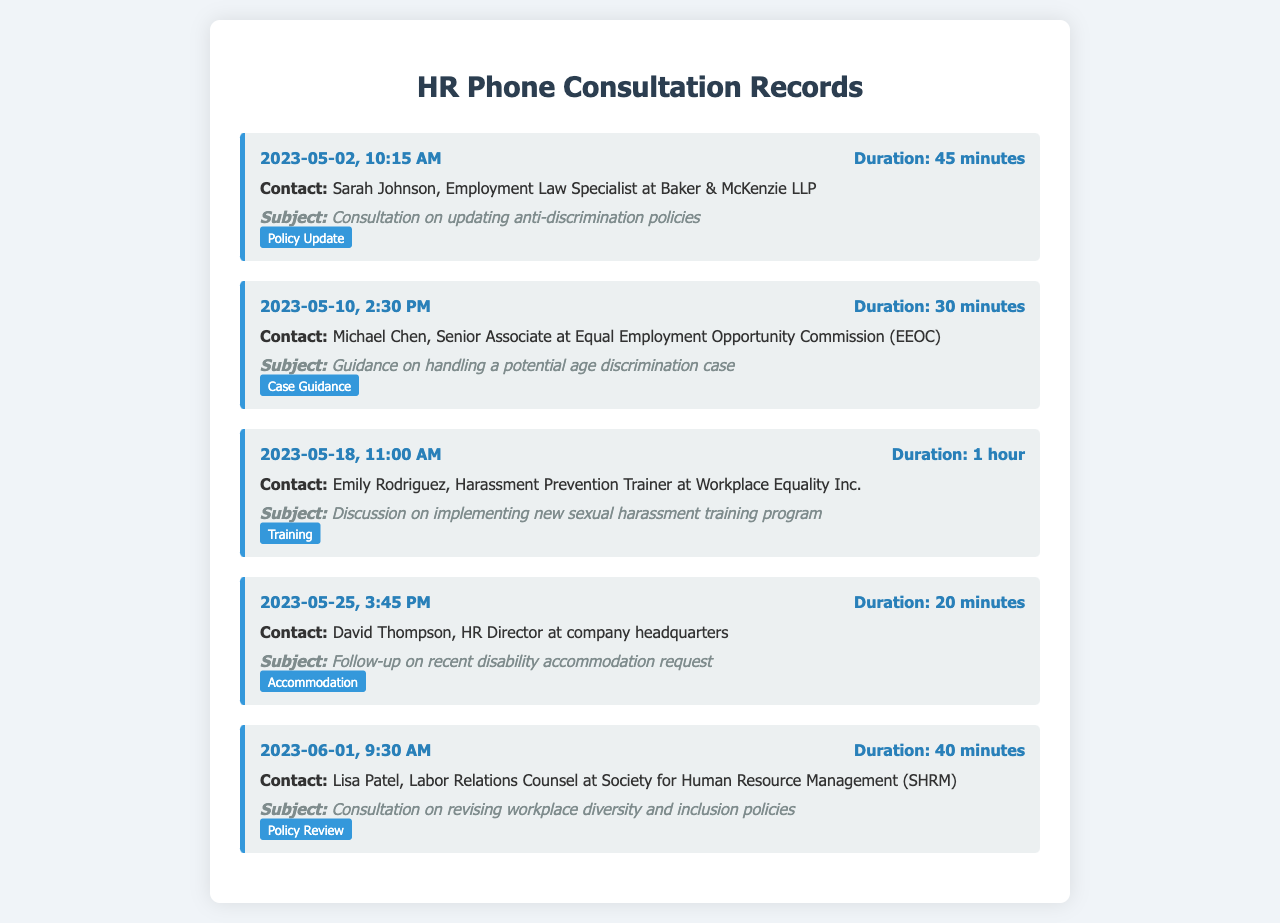what is the date of the consultation with Sarah Johnson? The consultation with Sarah Johnson occurred on May 2, 2023.
Answer: May 2, 2023 who did the HR associate consult regarding a potential age discrimination case? The HR associate consulted Michael Chen regarding a potential age discrimination case.
Answer: Michael Chen how long was the consultation about the new sexual harassment training program? The consultation about the new sexual harassment training program lasted 1 hour.
Answer: 1 hour which organization is Emily Rodriguez affiliated with? Emily Rodriguez is affiliated with Workplace Equality Inc.
Answer: Workplace Equality Inc what is the subject of the call on May 25, 2023? The subject of the call on May 25, 2023, was a follow-up on a recent disability accommodation request.
Answer: Follow-up on recent disability accommodation request how many minutes were spent consulting with Lisa Patel? The consultation with Lisa Patel lasted 40 minutes.
Answer: 40 minutes which tag is associated with the consultation on updating anti-discrimination policies? The tag associated with the consultation on updating anti-discrimination policies is "Policy Update."
Answer: Policy Update who was the contact for guidance on handling a potential age discrimination case? The contact for guidance on handling a potential age discrimination case was Michael Chen.
Answer: Michael Chen what was the duration of the consultation with David Thompson? The duration of the consultation with David Thompson was 20 minutes.
Answer: 20 minutes 